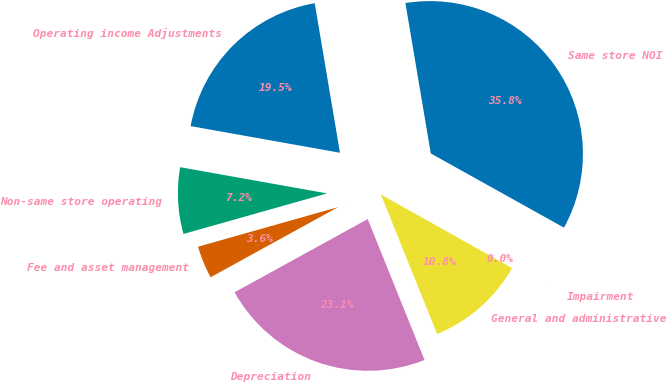Convert chart. <chart><loc_0><loc_0><loc_500><loc_500><pie_chart><fcel>Operating income Adjustments<fcel>Non-same store operating<fcel>Fee and asset management<fcel>Depreciation<fcel>General and administrative<fcel>Impairment<fcel>Same store NOI<nl><fcel>19.53%<fcel>7.19%<fcel>3.62%<fcel>23.1%<fcel>10.76%<fcel>0.05%<fcel>35.75%<nl></chart> 